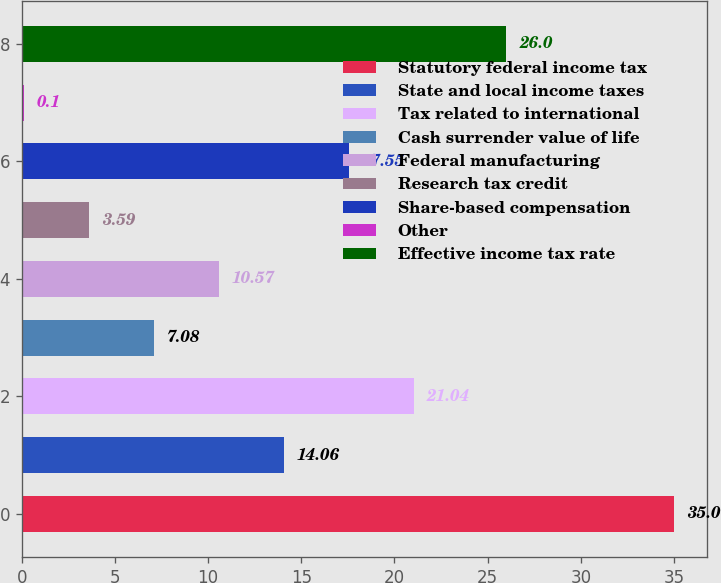Convert chart to OTSL. <chart><loc_0><loc_0><loc_500><loc_500><bar_chart><fcel>Statutory federal income tax<fcel>State and local income taxes<fcel>Tax related to international<fcel>Cash surrender value of life<fcel>Federal manufacturing<fcel>Research tax credit<fcel>Share-based compensation<fcel>Other<fcel>Effective income tax rate<nl><fcel>35<fcel>14.06<fcel>21.04<fcel>7.08<fcel>10.57<fcel>3.59<fcel>17.55<fcel>0.1<fcel>26<nl></chart> 